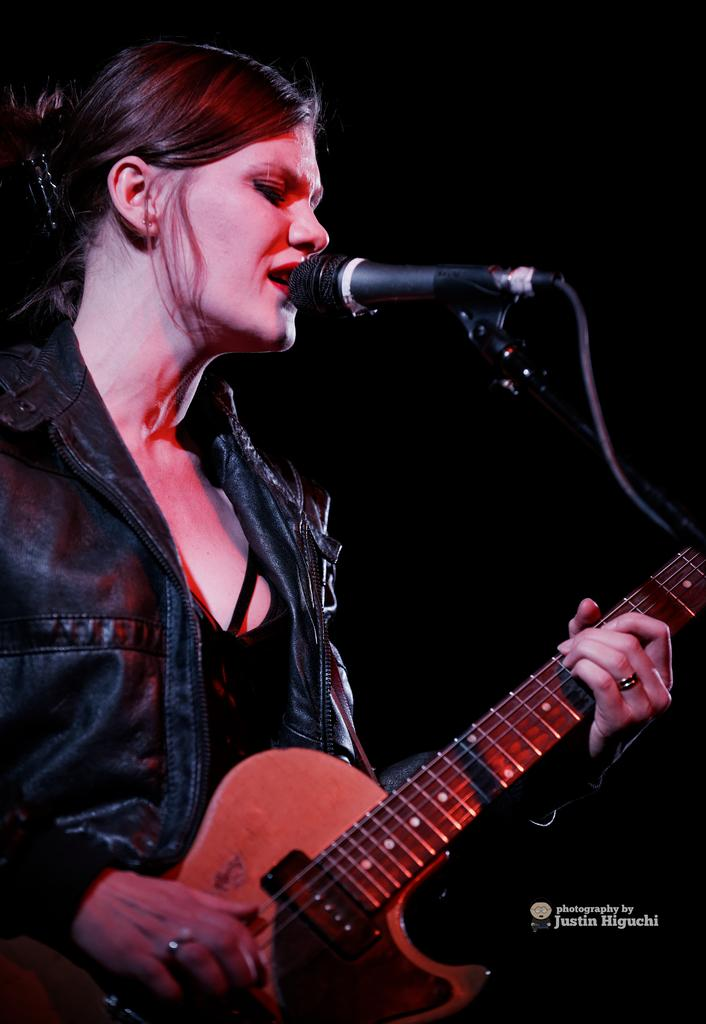Who is the main subject in the image? There is a woman in the image. What is the woman doing in the image? The woman is singing and playing a guitar. What object is the woman holding in the image? The woman is holding a microphone in the image. What type of curve can be seen on the woman's face in the image? There is no curve mentioned on the woman's face in the image. Is there a kitty visible in the image? No, there is no kitty present in the image. 